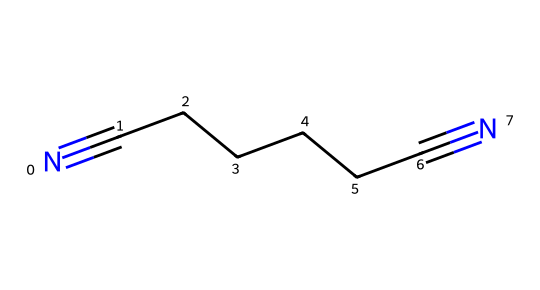What is the chemical name of the structure shown? The structure corresponds to a compound with the SMILES representation "N#CCCCCC#N", which indicates that the compound consists of a linear chain of six carbon atoms with nitrile (−CN) groups at each end. The common name for this compound is adiponitrile.
Answer: adiponitrile How many carbon atoms are present in this structure? By analyzing the SMILES representation, "N#CCCCCC#N", we can count the number of 'C' (carbon) atoms listed. In total, there are 6 carbon atoms in this structure that form a continuous chain.
Answer: 6 What type of functional groups are present in this molecule? The SMILES representation shows "N#N" at both ends, indicating the presence of nitrile functional groups (−C≡N) attached to the carbon chain. Therefore, the functional groups in the molecule are nitriles.
Answer: nitriles What is the total number of nitrogen atoms in this structure? The SMILES representation contains "N#N", which indicates two nitrogen atoms at both ends of the carbon chain. Thus, there are a total of 2 nitrogen atoms in the molecule.
Answer: 2 Does this molecule have any double or triple bonds? According to the SMILES, the "N#" represents a triple bond between the nitrogen and the carbon, confirming that the functional group present is the nitrile group. The carbon chain itself contains only single bonds.
Answer: triple bond What would be the impact of the nitrile functional groups on the properties of the molecule? Nitrile groups can influence properties like solubility and reactivity due to their electronic properties. They can participate in various chemical reactions, including hydrolysis to form amides. The overall impact is an increase in polarity and a potential for reactivity.
Answer: increased polarity and reactivity 